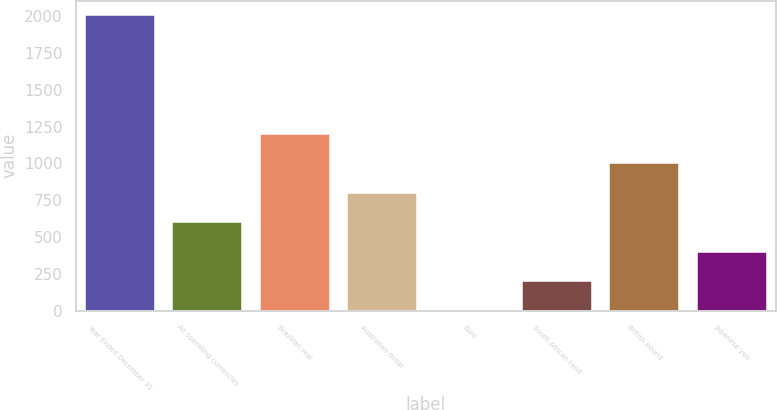Convert chart to OTSL. <chart><loc_0><loc_0><loc_500><loc_500><bar_chart><fcel>Year Ended December 31<fcel>All operating currencies<fcel>Brazilian real<fcel>Australian dollar<fcel>Euro<fcel>South African rand<fcel>British pound<fcel>Japanese yen<nl><fcel>2005<fcel>602.2<fcel>1203.4<fcel>802.6<fcel>1<fcel>201.4<fcel>1003<fcel>401.8<nl></chart> 